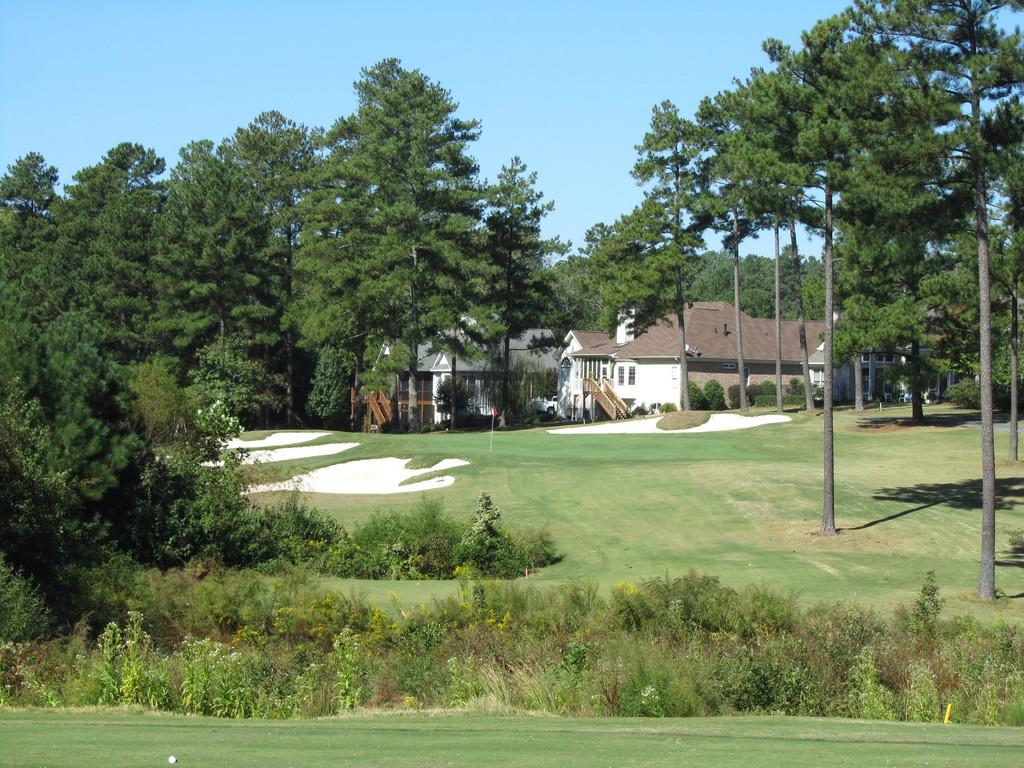What type of vegetation is in the foreground of the image? There is grass and plants in the foreground of the image. What can be seen in the background of the image? There are trees, grasslands, a golf ground, buildings, and the sky visible in the background of the image. What idea does the boy have while standing on the rock in the image? There is no boy or rock present in the image. What type of creature can be seen interacting with the grass in the foreground of the image? There is no creature shown interacting with the grass in the foreground of the image; only plants and grass are present. 